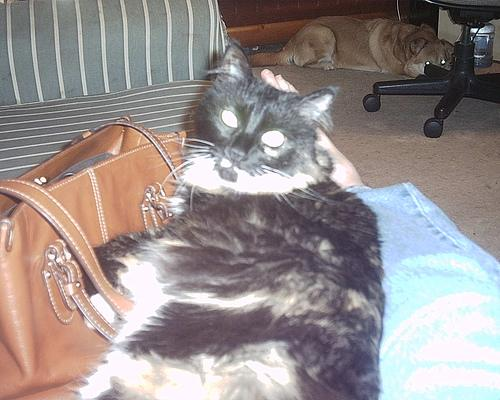What human body part does the cat lean back on? Please explain your reasoning. leg. A foot can be seen by the cat. 